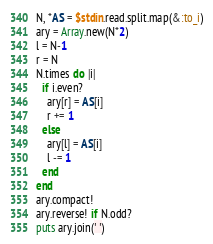<code> <loc_0><loc_0><loc_500><loc_500><_Ruby_>N, *AS = $stdin.read.split.map(&:to_i)
ary = Array.new(N*2)
l = N-1
r = N
N.times do |i|
  if i.even?
    ary[r] = AS[i]
    r += 1
  else
    ary[l] = AS[i]
    l -= 1
  end
end
ary.compact!
ary.reverse! if N.odd?
puts ary.join(' ')
</code> 